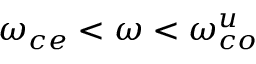<formula> <loc_0><loc_0><loc_500><loc_500>\omega _ { c e } < \omega < \omega _ { c o } ^ { u }</formula> 